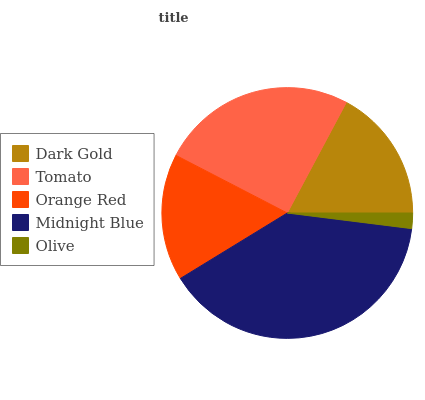Is Olive the minimum?
Answer yes or no. Yes. Is Midnight Blue the maximum?
Answer yes or no. Yes. Is Tomato the minimum?
Answer yes or no. No. Is Tomato the maximum?
Answer yes or no. No. Is Tomato greater than Dark Gold?
Answer yes or no. Yes. Is Dark Gold less than Tomato?
Answer yes or no. Yes. Is Dark Gold greater than Tomato?
Answer yes or no. No. Is Tomato less than Dark Gold?
Answer yes or no. No. Is Dark Gold the high median?
Answer yes or no. Yes. Is Dark Gold the low median?
Answer yes or no. Yes. Is Tomato the high median?
Answer yes or no. No. Is Tomato the low median?
Answer yes or no. No. 